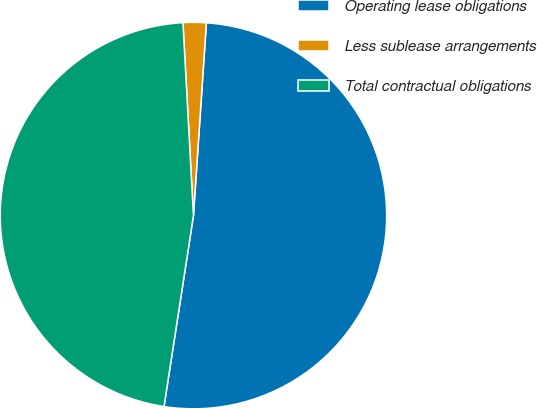Convert chart. <chart><loc_0><loc_0><loc_500><loc_500><pie_chart><fcel>Operating lease obligations<fcel>Less sublease arrangements<fcel>Total contractual obligations<nl><fcel>51.37%<fcel>1.93%<fcel>46.7%<nl></chart> 